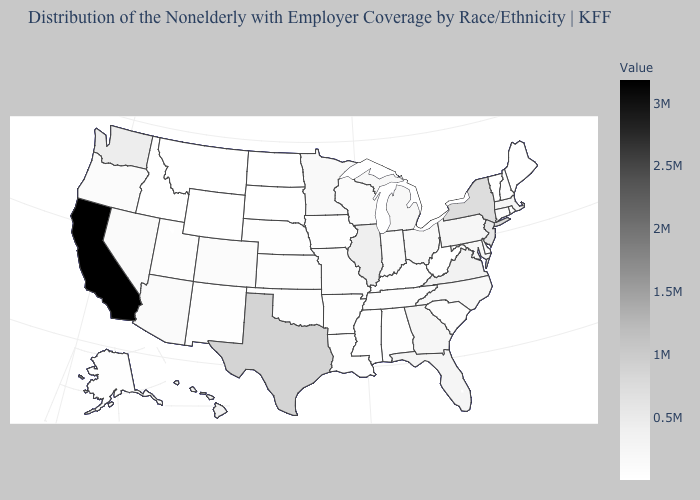Which states have the highest value in the USA?
Answer briefly. California. Does Washington have a lower value than California?
Short answer required. Yes. Among the states that border South Carolina , does North Carolina have the lowest value?
Answer briefly. Yes. Does the map have missing data?
Give a very brief answer. No. Among the states that border Idaho , does Wyoming have the lowest value?
Short answer required. Yes. Which states have the lowest value in the USA?
Answer briefly. Wyoming. Which states have the lowest value in the USA?
Short answer required. Wyoming. Among the states that border Alabama , does Florida have the highest value?
Write a very short answer. Yes. Does Vermont have the lowest value in the Northeast?
Quick response, please. Yes. 